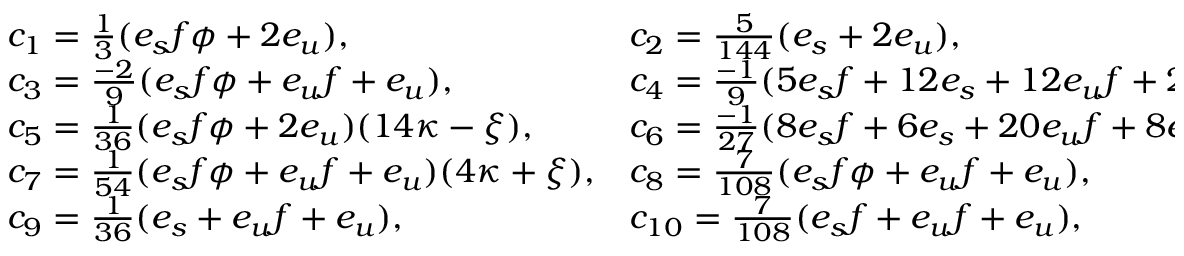Convert formula to latex. <formula><loc_0><loc_0><loc_500><loc_500>\begin{array} { l l } { { c _ { 1 } = { \frac { 1 } { 3 } } ( e _ { s } f \phi + 2 e _ { u } ) , } } & { { c _ { 2 } = { \frac { 5 } { 1 4 4 } } ( e _ { s } + 2 e _ { u } ) , } } \\ { { c _ { 3 } = { \frac { - 2 } { 9 } } ( e _ { s } f \phi + e _ { u } f + e _ { u } ) , } } & { { c _ { 4 } = { \frac { - 1 } { 9 } } ( 5 e _ { s } f + 1 2 e _ { s } + 1 2 e _ { u } f + 2 2 e _ { u } ) , } } \\ { { c _ { 5 } = { \frac { 1 } { 3 6 } } ( e _ { s } f \phi + 2 e _ { u } ) ( 1 4 \kappa - \xi ) , } } & { { c _ { 6 } = { \frac { - 1 } { 2 7 } } ( 8 e _ { s } f + 6 e _ { s } + 2 0 e _ { u } f + 8 e _ { u } ) \kappa _ { v } , } } \\ { { c _ { 7 } = { \frac { 1 } { 5 4 } } ( e _ { s } f \phi + e _ { u } f + e _ { u } ) ( 4 \kappa + \xi ) , } } & { { c _ { 8 } = { \frac { 7 } { 1 0 8 } } ( e _ { s } f \phi + e _ { u } f + e _ { u } ) , } } \\ { { c _ { 9 } = { \frac { 1 } { 3 6 } } ( e _ { s } + e _ { u } f + e _ { u } ) , } } & { { c _ { 1 0 } = { \frac { 7 } { 1 0 8 } } ( e _ { s } f + e _ { u } f + e _ { u } ) , } } \end{array}</formula> 